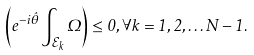<formula> <loc_0><loc_0><loc_500><loc_500>\left ( e ^ { - i \hat { \theta } } \int _ { \mathcal { E } _ { k } } \Omega \right ) \leq 0 , \forall k = 1 , 2 , \dots N - 1 .</formula> 